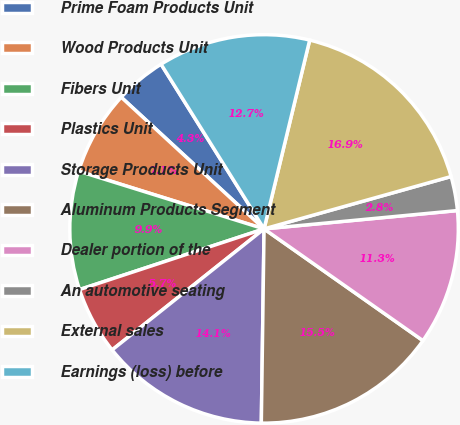<chart> <loc_0><loc_0><loc_500><loc_500><pie_chart><fcel>Prime Foam Products Unit<fcel>Wood Products Unit<fcel>Fibers Unit<fcel>Plastics Unit<fcel>Storage Products Unit<fcel>Aluminum Products Segment<fcel>Dealer portion of the<fcel>An automotive seating<fcel>External sales<fcel>Earnings (loss) before<nl><fcel>4.25%<fcel>7.05%<fcel>9.86%<fcel>5.65%<fcel>14.07%<fcel>15.47%<fcel>11.26%<fcel>2.84%<fcel>16.88%<fcel>12.67%<nl></chart> 